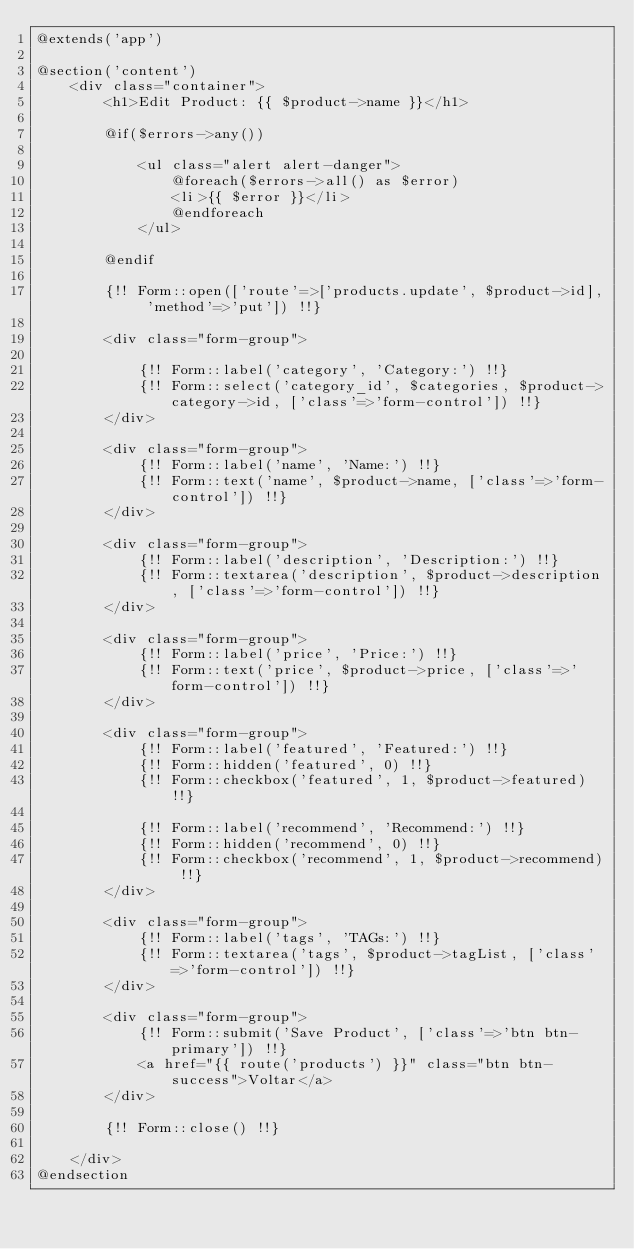Convert code to text. <code><loc_0><loc_0><loc_500><loc_500><_PHP_>@extends('app')

@section('content')
    <div class="container">
        <h1>Edit Product: {{ $product->name }}</h1>

        @if($errors->any())

            <ul class="alert alert-danger">
                @foreach($errors->all() as $error)
                <li>{{ $error }}</li>
                @endforeach
            </ul>

        @endif

        {!! Form::open(['route'=>['products.update', $product->id], 'method'=>'put']) !!}

        <div class="form-group">

            {!! Form::label('category', 'Category:') !!}
            {!! Form::select('category_id', $categories, $product->category->id, ['class'=>'form-control']) !!}
        </div>

        <div class="form-group">
            {!! Form::label('name', 'Name:') !!}
            {!! Form::text('name', $product->name, ['class'=>'form-control']) !!}
        </div>

        <div class="form-group">
            {!! Form::label('description', 'Description:') !!}
            {!! Form::textarea('description', $product->description, ['class'=>'form-control']) !!}
        </div>

        <div class="form-group">
            {!! Form::label('price', 'Price:') !!}
            {!! Form::text('price', $product->price, ['class'=>'form-control']) !!}
        </div>

        <div class="form-group">
            {!! Form::label('featured', 'Featured:') !!}
            {!! Form::hidden('featured', 0) !!}
            {!! Form::checkbox('featured', 1, $product->featured) !!}

            {!! Form::label('recommend', 'Recommend:') !!}
            {!! Form::hidden('recommend', 0) !!}
            {!! Form::checkbox('recommend', 1, $product->recommend) !!}
        </div>

        <div class="form-group">
            {!! Form::label('tags', 'TAGs:') !!}
            {!! Form::textarea('tags', $product->tagList, ['class'=>'form-control']) !!}
        </div>

        <div class="form-group">
            {!! Form::submit('Save Product', ['class'=>'btn btn-primary']) !!}
            <a href="{{ route('products') }}" class="btn btn-success">Voltar</a>
        </div>

        {!! Form::close() !!}

    </div>
@endsection</code> 